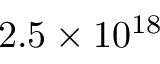Convert formula to latex. <formula><loc_0><loc_0><loc_500><loc_500>2 . 5 \times 1 0 ^ { 1 8 }</formula> 